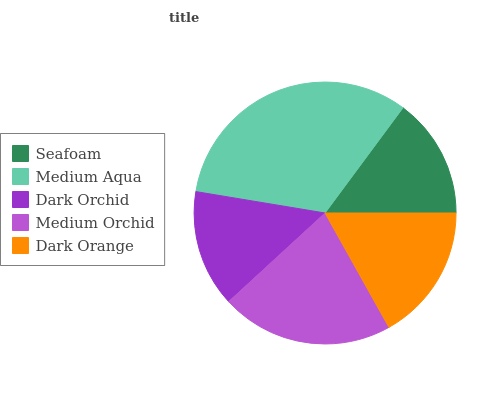Is Dark Orchid the minimum?
Answer yes or no. Yes. Is Medium Aqua the maximum?
Answer yes or no. Yes. Is Medium Aqua the minimum?
Answer yes or no. No. Is Dark Orchid the maximum?
Answer yes or no. No. Is Medium Aqua greater than Dark Orchid?
Answer yes or no. Yes. Is Dark Orchid less than Medium Aqua?
Answer yes or no. Yes. Is Dark Orchid greater than Medium Aqua?
Answer yes or no. No. Is Medium Aqua less than Dark Orchid?
Answer yes or no. No. Is Dark Orange the high median?
Answer yes or no. Yes. Is Dark Orange the low median?
Answer yes or no. Yes. Is Seafoam the high median?
Answer yes or no. No. Is Dark Orchid the low median?
Answer yes or no. No. 